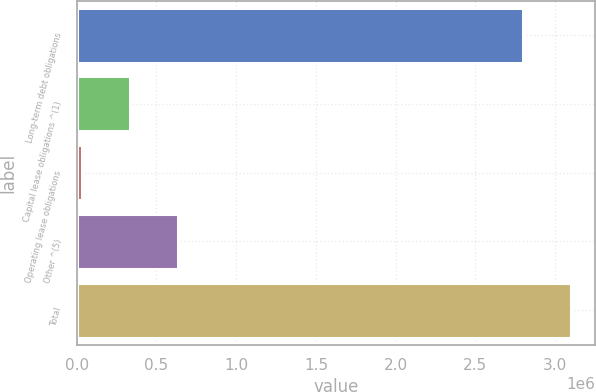<chart> <loc_0><loc_0><loc_500><loc_500><bar_chart><fcel>Long-term debt obligations<fcel>Capital lease obligations ^(1)<fcel>Operating lease obligations<fcel>Other ^(5)<fcel>Total<nl><fcel>2.79583e+06<fcel>336220<fcel>34356<fcel>638084<fcel>3.09769e+06<nl></chart> 